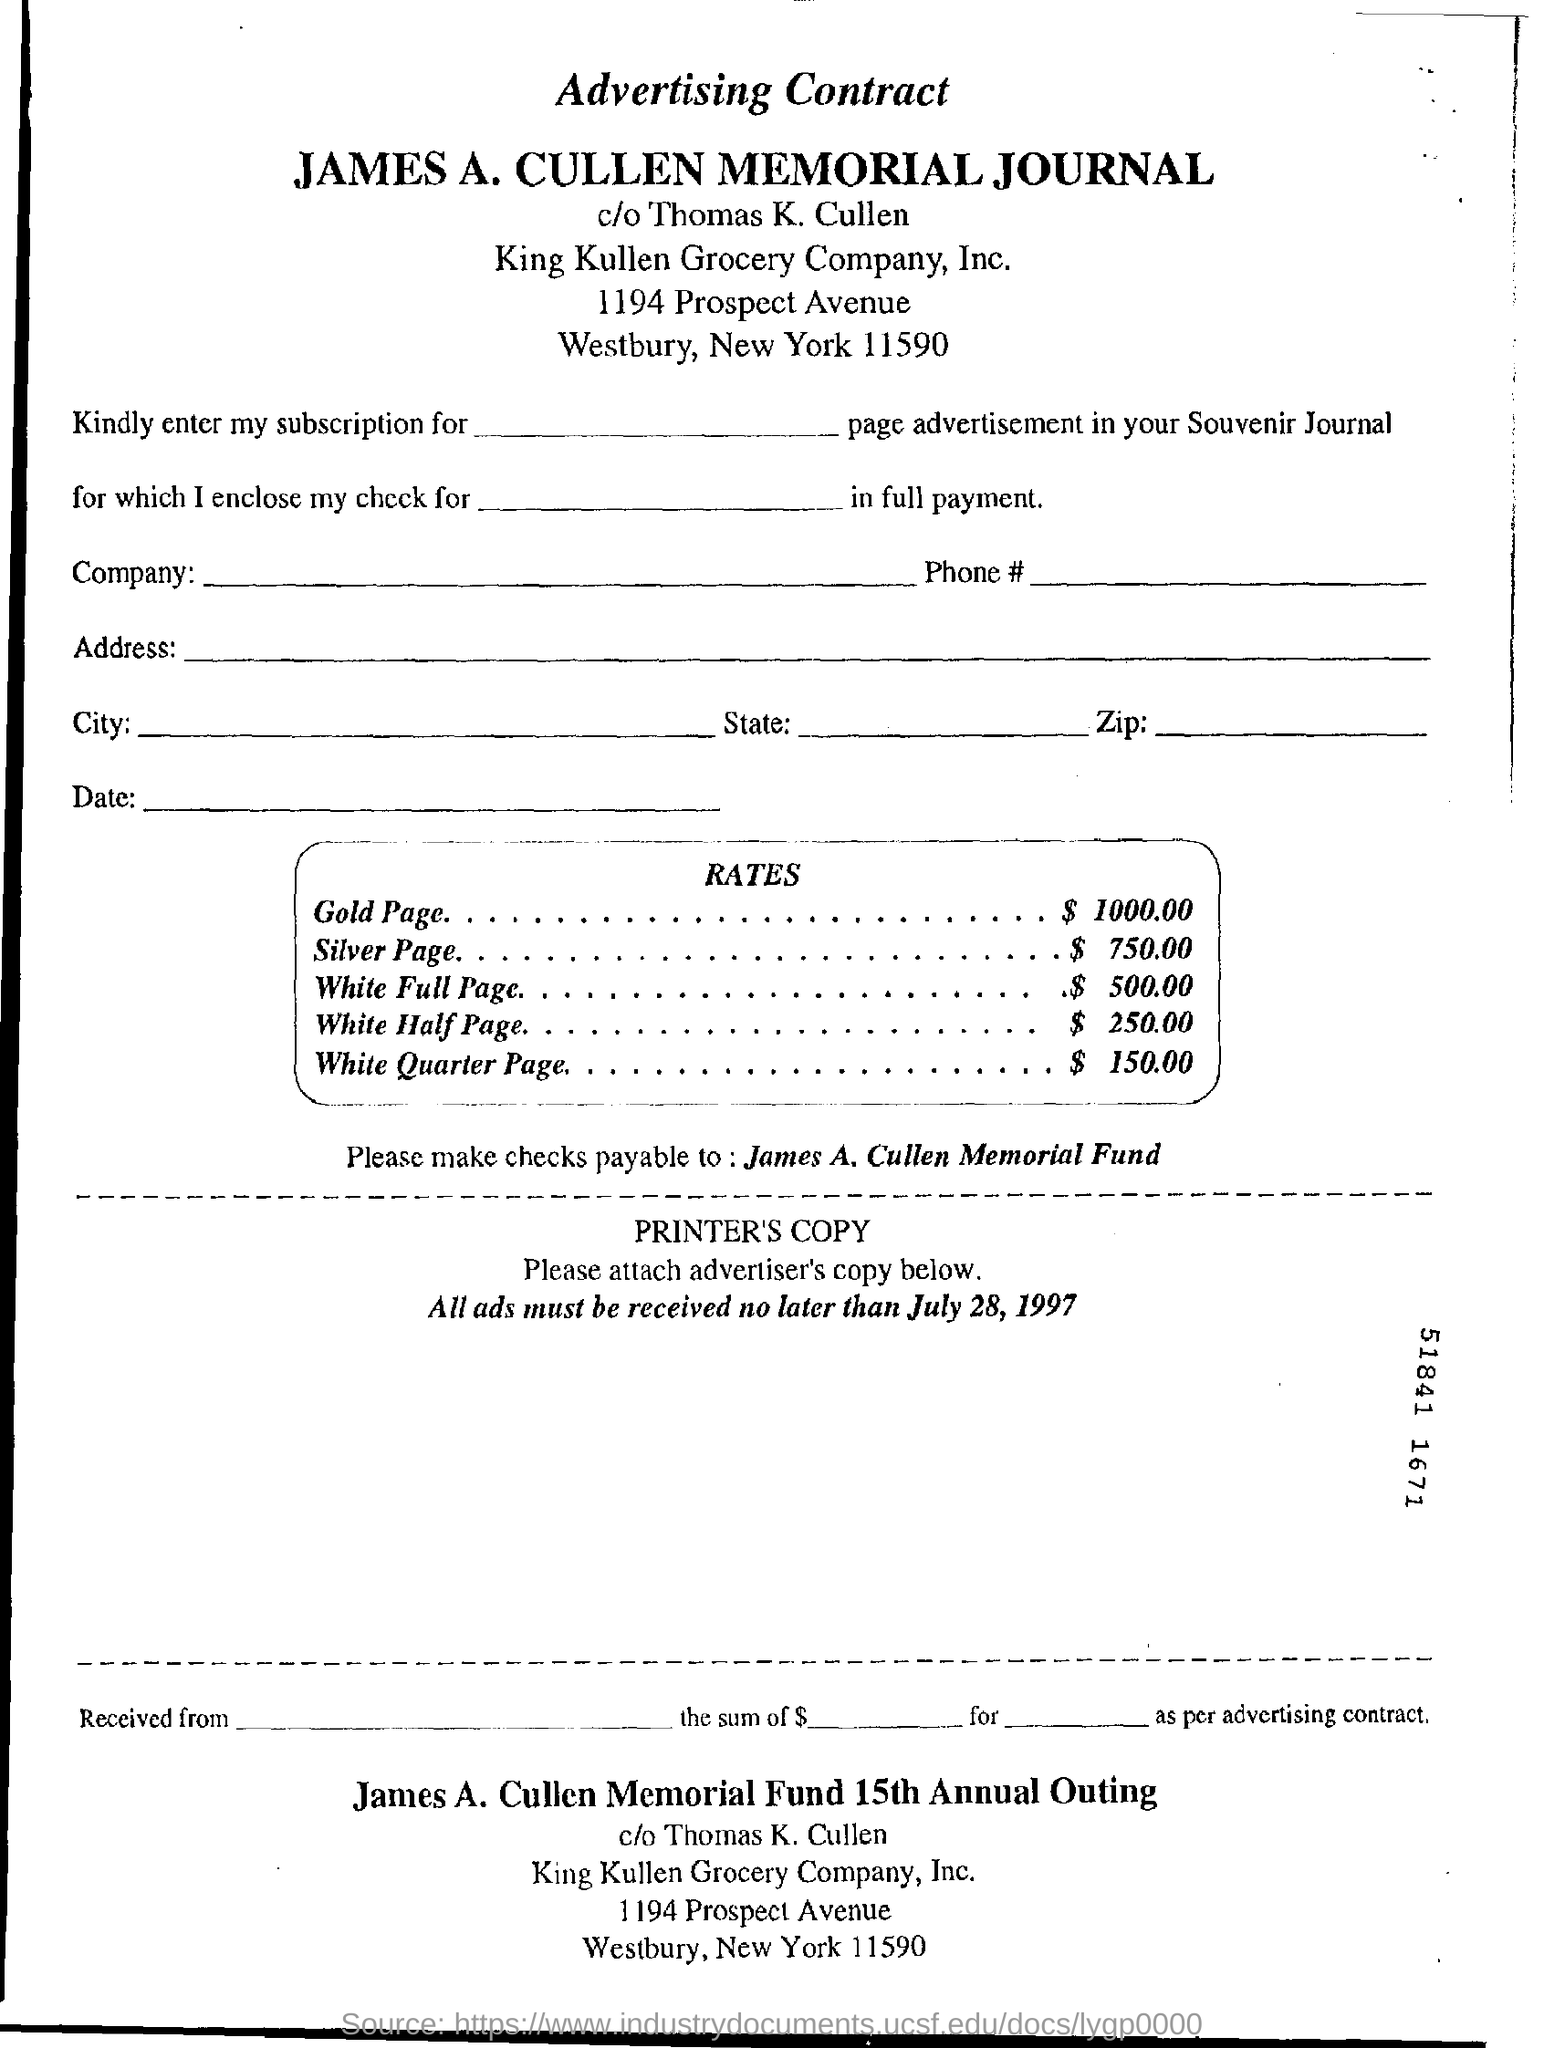List a handful of essential elements in this visual. The rate of gold is $1000. The rate for a white half page advertisement is $250.00. The last date to receive all ads is July 28, 1997. 